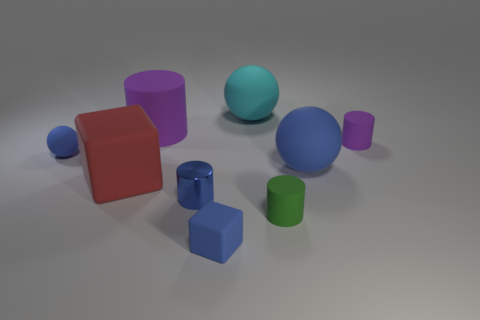What is the size of the other ball that is the same color as the small rubber sphere?
Provide a succinct answer. Large. Does the cyan matte thing have the same size as the red cube?
Your response must be concise. Yes. Does the large blue thing have the same shape as the red matte thing?
Keep it short and to the point. No. What is the shape of the green object?
Provide a succinct answer. Cylinder. How many other things are the same size as the green matte cylinder?
Offer a very short reply. 4. Are there the same number of tiny rubber balls on the left side of the small shiny object and blue cylinders?
Make the answer very short. Yes. Do the tiny object that is on the left side of the big purple object and the matte cube that is to the right of the large red block have the same color?
Give a very brief answer. Yes. What is the thing that is right of the metallic thing and to the left of the cyan sphere made of?
Make the answer very short. Rubber. What is the color of the tiny ball?
Offer a very short reply. Blue. What number of other things are there of the same shape as the big cyan object?
Provide a short and direct response. 2. 